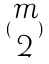<formula> <loc_0><loc_0><loc_500><loc_500>( \begin{matrix} m \\ 2 \end{matrix} )</formula> 